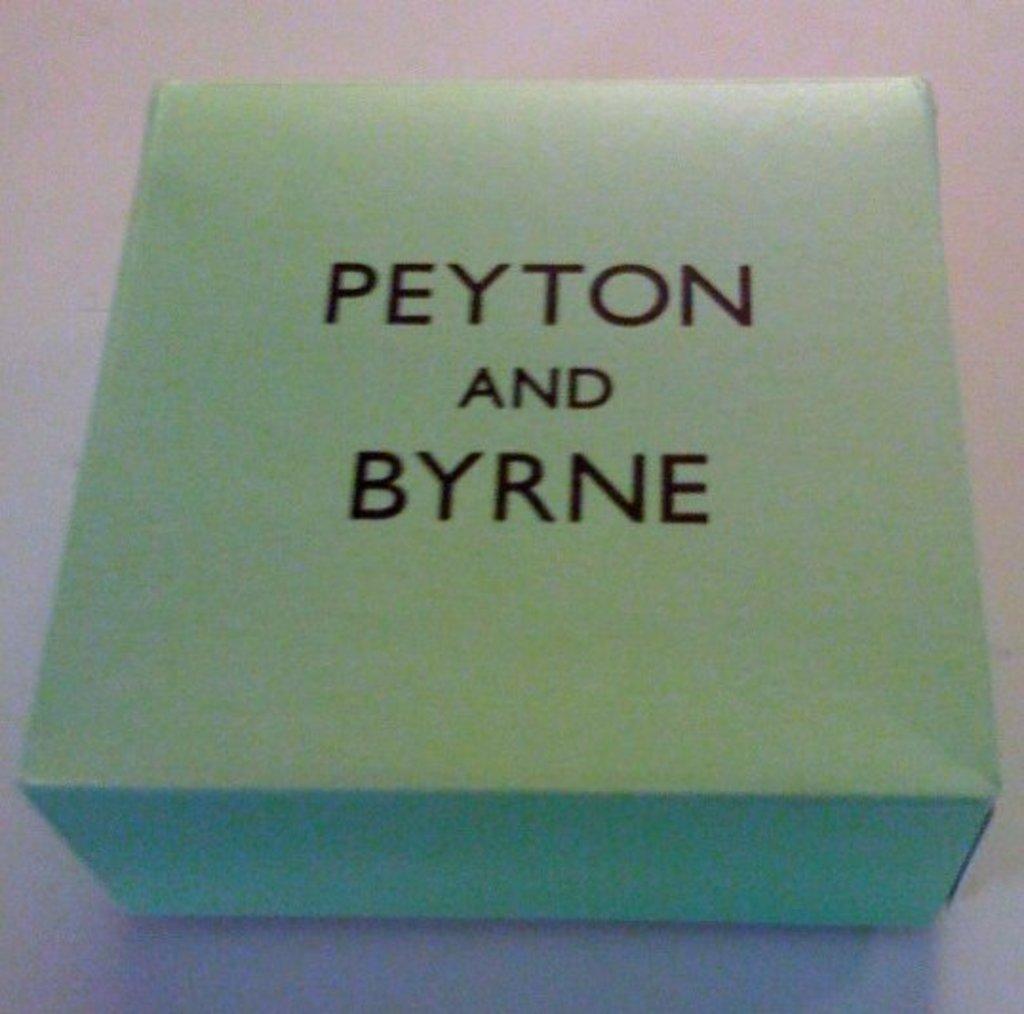What brand is his shorts?
Give a very brief answer. Unanswerable. 